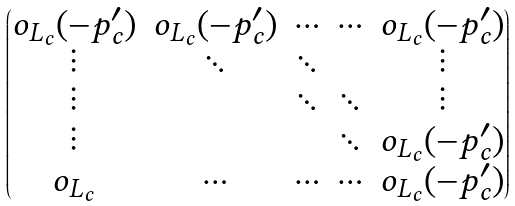<formula> <loc_0><loc_0><loc_500><loc_500>\begin{pmatrix} o _ { L _ { c } } ( - p ^ { \prime } _ { c } ) & o _ { L _ { c } } ( - p ^ { \prime } _ { c } ) & \cdots & \cdots & o _ { L _ { c } } ( - p ^ { \prime } _ { c } ) \\ \vdots & \ddots & \ddots & & \vdots \\ \vdots & & \ddots & \ddots & \vdots \\ \vdots & & & \ddots & o _ { L _ { c } } ( - p ^ { \prime } _ { c } ) \\ o _ { L _ { c } } & \cdots & \cdots & \cdots & o _ { L _ { c } } ( - p ^ { \prime } _ { c } ) \end{pmatrix}</formula> 